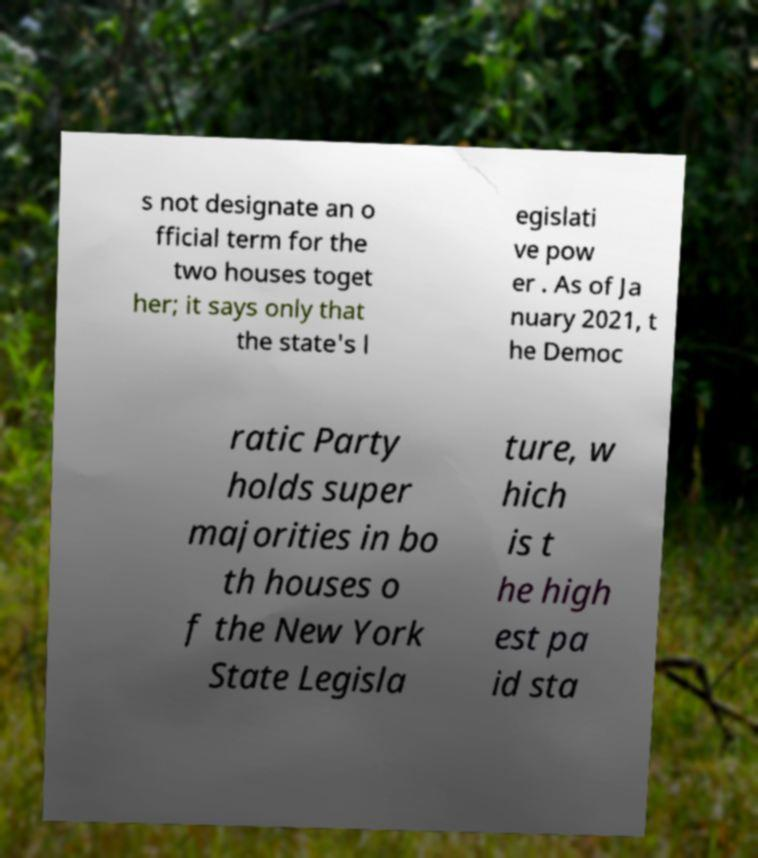There's text embedded in this image that I need extracted. Can you transcribe it verbatim? s not designate an o fficial term for the two houses toget her; it says only that the state's l egislati ve pow er . As of Ja nuary 2021, t he Democ ratic Party holds super majorities in bo th houses o f the New York State Legisla ture, w hich is t he high est pa id sta 